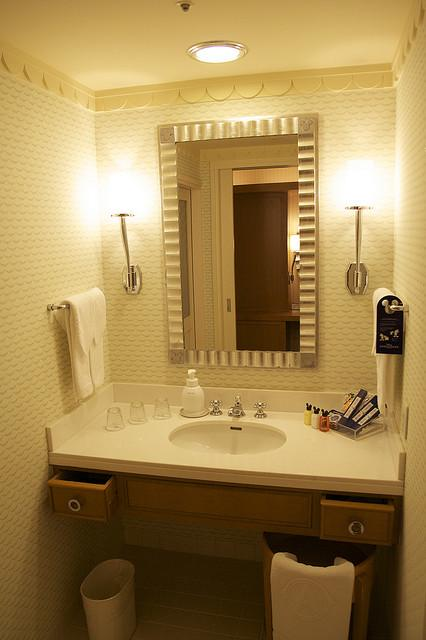Who provides the bottles on the counter? Please explain your reasoning. hotel. They are small sized complementary items for the customers use. 